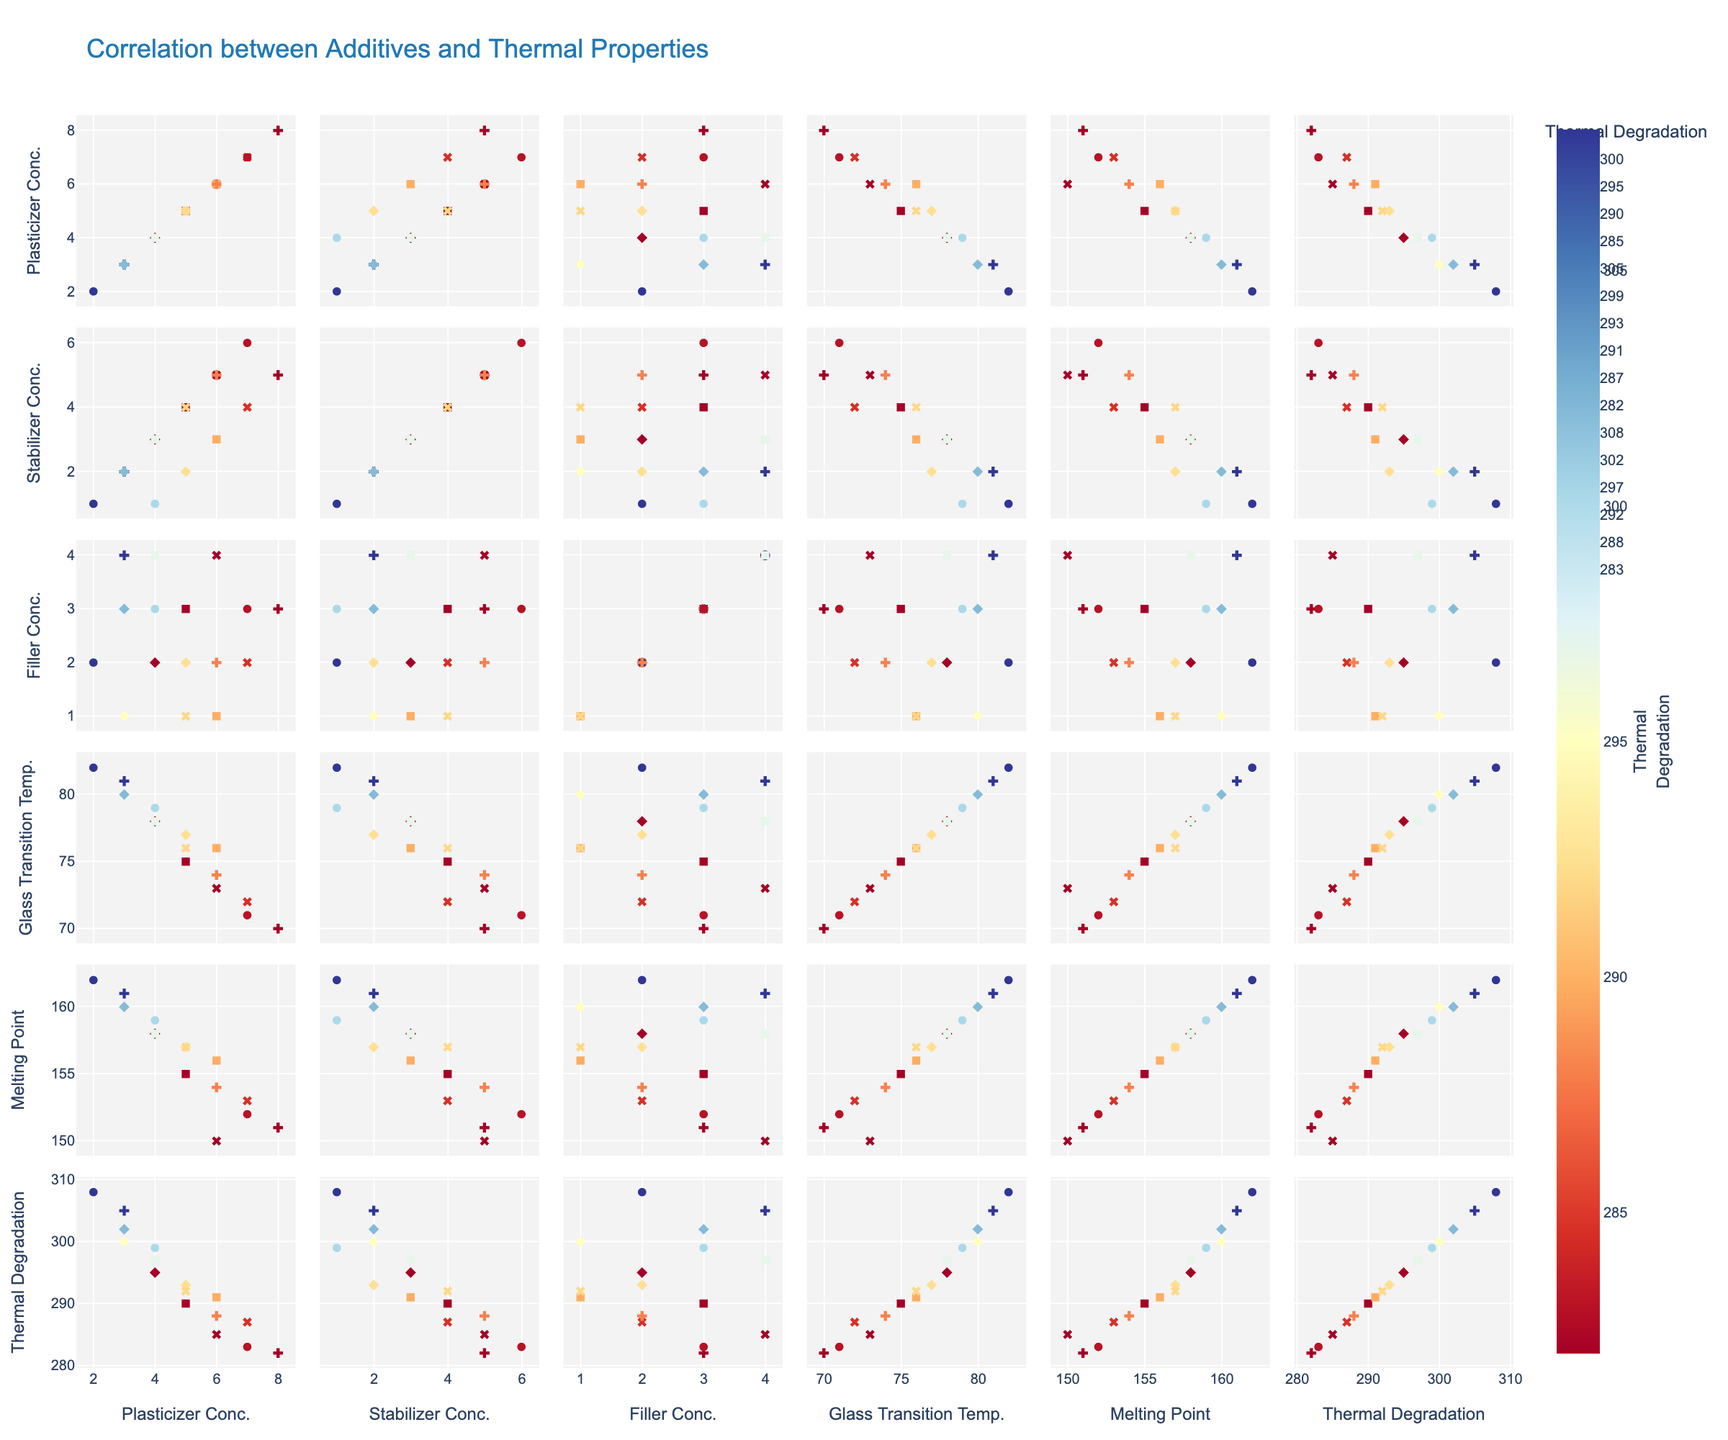What is the title of the scatter plot matrix? The title of the figure is located at the top center of the plot, typically in larger font size for emphasis.
Answer: Correlation between Additives and Thermal Properties What is the correlation between Plasticizer Concentration and Glass Transition Temperature? Locate the subplot corresponding to Plasticizer Concentration on the x-axis and Glass Transition Temperature on the y-axis. Observe the trend of the data points to infer correlation. As Plasticizer Concentration increases, Glass Transition Temperature tends to decrease, indicating a negative correlation.
Answer: Negative Among the additives, which one shows more variation in concentration values? Compare the range of concentration values for Plasticizer, Stabilizer, and Filler by observing their respective axes in the scatter plot matrix. Plasticizer Concentration ranges from 2 to 8, Stabilizer from 1 to 6, and Filler from 1 to 4. Plasticizer has the widest range.
Answer: Plasticizer What is the relationship between Melting Point and Thermal Degradation? Locate the subplot with Melting Point on the x-axis and Thermal Degradation on the y-axis. Observe the distribution of data points. As the Melting Point increases, Thermal Degradation tends to increase, showing a positive correlation.
Answer: Positive Which thermal property seems least affected by additive concentrations? Examine the subplots where each thermal property (Glass Transition Temperature, Melting Point, Thermal Degradation) is compared with additive concentrations (Plasticizer, Stabilizer, Filler). Glass Transition Temperature shows more consistent and stronger trends with the additive concentrations compared to Melting Point and Thermal Degradation. Therefore, Melting Point appears to be least affected.
Answer: Melting Point For a Polymer sample with Plasticizer Concentration 5, which thermal property values are observed? Find the data points where the x-axis is Plasticizer Concentration 5. Observe the corresponding values on the y-axes for each thermal property (Glass Transition Temperature, Melting Point, Thermal Degradation).
Answer: Glass Transition Temperature ≈ 77, Melting Point ≈ 157, Thermal Degradation ≈ 292 How does the concentration of Fillers affect Thermal Degradation? Identify the subplot where Filler Concentration is on the x-axis and Thermal Degradation is on the y-axis. Observe the distribution and trend of data points. As Filler Concentration increases, Thermal Degradation also tends to increase, showing a positive correlation.
Answer: Positive Which pair of additive concentrations shows the strongest correlation? Compare all subplots where the x and y axes represent different additive concentrations (Plasticizer, Stabilizer, Filler). The pair with the most linear trend indicates the strongest correlation. Plasticizer and Stabilizer Concentrations show the strongest positive correlation.
Answer: Plasticizer and Stabilizer What is the effect of increasing Stabilizer Concentration on Glass Transition Temperature? Find the subplot with Stabilizer Concentration on the x-axis and Glass Transition Temperature on the y-axis. Observe the trend of data points. As Stabilizer Concentration increases, Glass Transition Temperature tends to decrease, indicating a negative correlation.
Answer: Negative Which thermal property has a clearer trend with increasing Plasticizer Concentration? Examine the subplots where Plasticizer Concentration is the x-axis and each thermal property is the y-axis. Glass Transition Temperature shows the most noticeable and consistent decrease as Plasticizer Concentration increases.
Answer: Glass Transition Temperature 